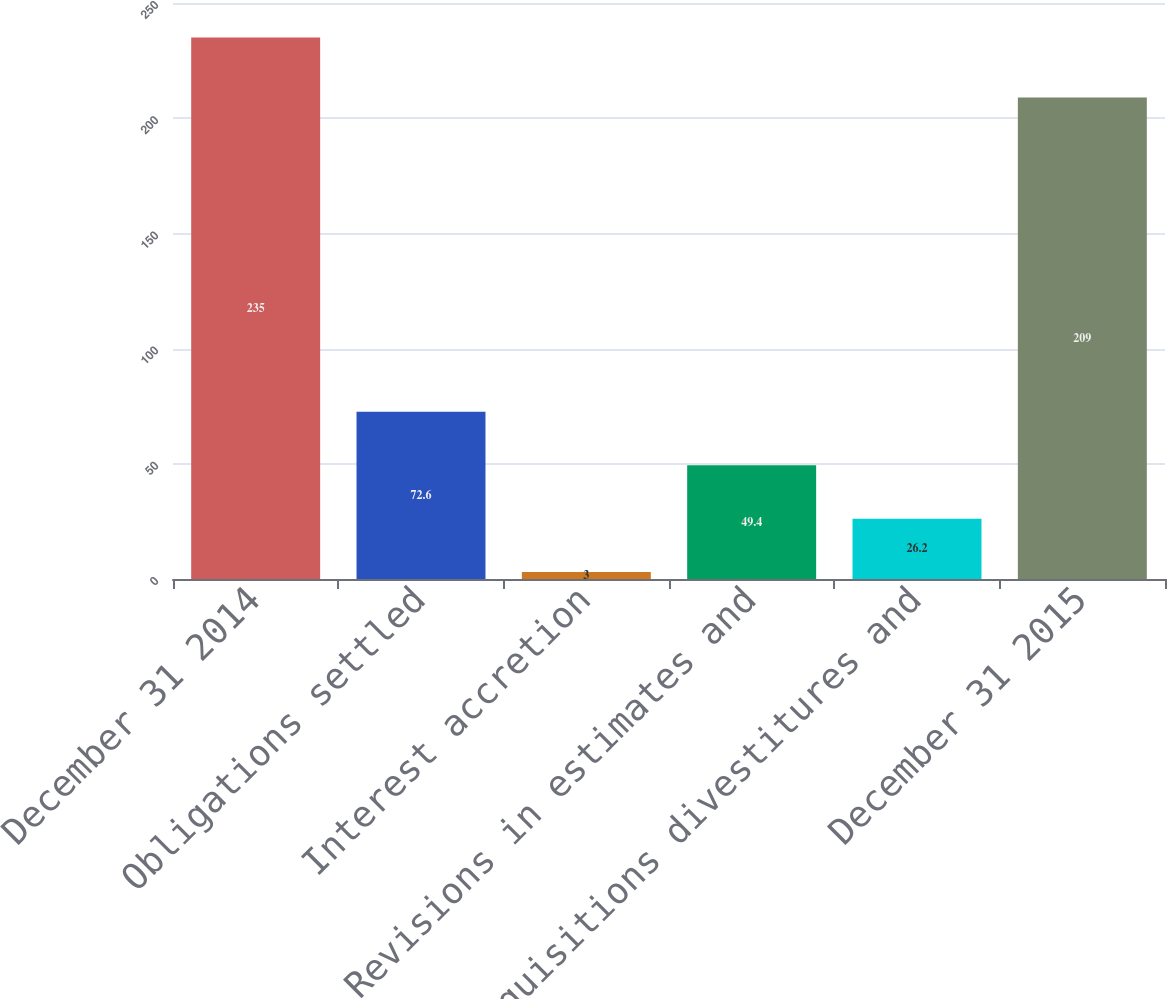Convert chart. <chart><loc_0><loc_0><loc_500><loc_500><bar_chart><fcel>December 31 2014<fcel>Obligations settled<fcel>Interest accretion<fcel>Revisions in estimates and<fcel>Acquisitions divestitures and<fcel>December 31 2015<nl><fcel>235<fcel>72.6<fcel>3<fcel>49.4<fcel>26.2<fcel>209<nl></chart> 